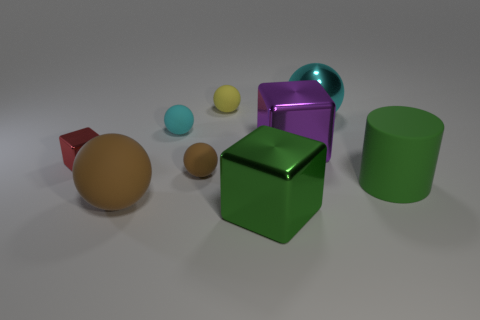Are there any objects that could change the overall color scheme if removed? Removing the bright cyan ball would slightly alter the image's color balance, reducing the impact of cool tones and making warm tones slightly more dominant. 